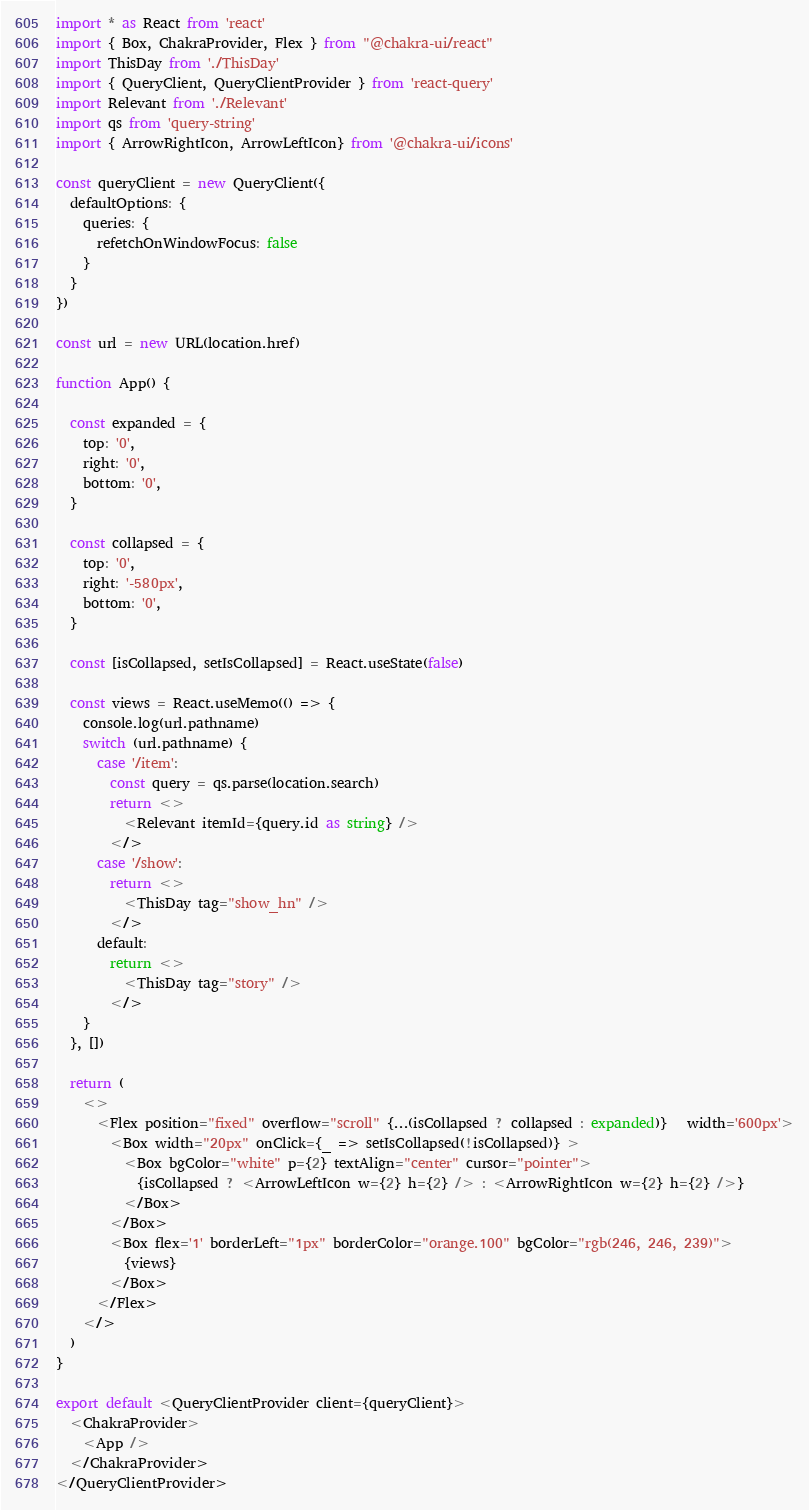Convert code to text. <code><loc_0><loc_0><loc_500><loc_500><_TypeScript_>import * as React from 'react'
import { Box, ChakraProvider, Flex } from "@chakra-ui/react"
import ThisDay from './ThisDay'
import { QueryClient, QueryClientProvider } from 'react-query'
import Relevant from './Relevant'
import qs from 'query-string'
import { ArrowRightIcon, ArrowLeftIcon} from '@chakra-ui/icons'

const queryClient = new QueryClient({
  defaultOptions: {
    queries: {
      refetchOnWindowFocus: false
    }
  }
})

const url = new URL(location.href)

function App() {

  const expanded = {
    top: '0',
    right: '0',
    bottom: '0',
  }

  const collapsed = {
    top: '0',
    right: '-580px',
    bottom: '0', 
  }

  const [isCollapsed, setIsCollapsed] = React.useState(false)

  const views = React.useMemo(() => {
    console.log(url.pathname)
    switch (url.pathname) {
      case '/item':
        const query = qs.parse(location.search)
        return <>
          <Relevant itemId={query.id as string} />
        </>
      case '/show':
        return <>
          <ThisDay tag="show_hn" />
        </>
      default:
        return <>
          <ThisDay tag="story" />
        </>
    }
  }, [])

  return (
    <>
      <Flex position="fixed" overflow="scroll" {...(isCollapsed ? collapsed : expanded)}   width='600px'>
        <Box width="20px" onClick={_ => setIsCollapsed(!isCollapsed)} >
          <Box bgColor="white" p={2} textAlign="center" cursor="pointer">
            {isCollapsed ? <ArrowLeftIcon w={2} h={2} /> : <ArrowRightIcon w={2} h={2} />}
          </Box>
        </Box>
        <Box flex='1' borderLeft="1px" borderColor="orange.100" bgColor="rgb(246, 246, 239)">
          {views}
        </Box>
      </Flex>
    </>
  )
}

export default <QueryClientProvider client={queryClient}>
  <ChakraProvider>
    <App />
  </ChakraProvider>
</QueryClientProvider>
</code> 